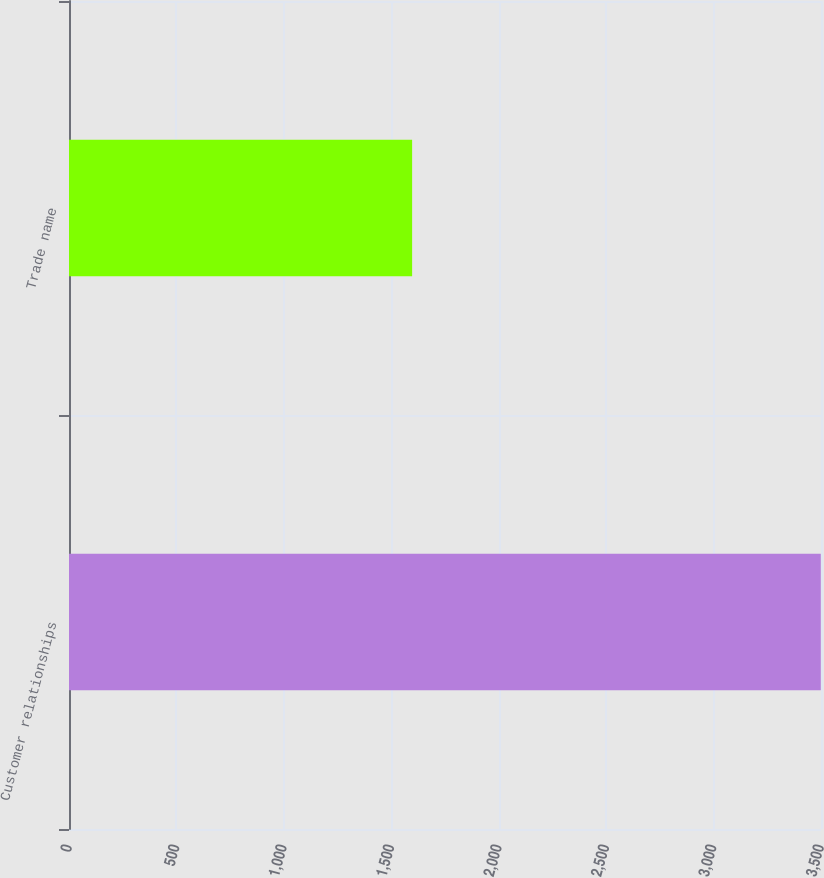<chart> <loc_0><loc_0><loc_500><loc_500><bar_chart><fcel>Customer relationships<fcel>Trade name<nl><fcel>3499<fcel>1597<nl></chart> 